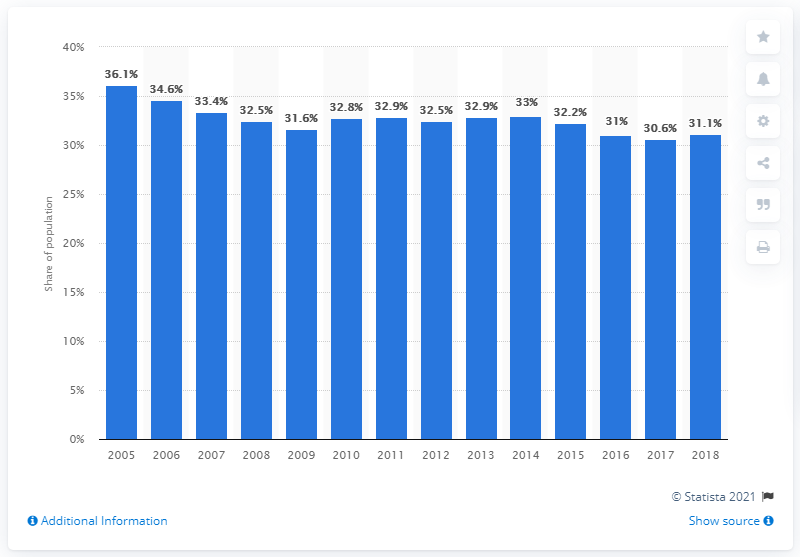Highlight a few significant elements in this photo. During the period of 2005 to 2018, the share of tenants in the Netherlands was 31.1%. 